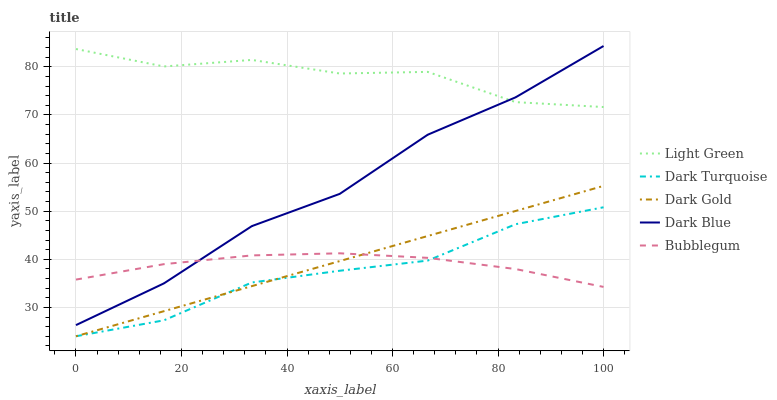Does Dark Turquoise have the minimum area under the curve?
Answer yes or no. Yes. Does Light Green have the maximum area under the curve?
Answer yes or no. Yes. Does Bubblegum have the minimum area under the curve?
Answer yes or no. No. Does Bubblegum have the maximum area under the curve?
Answer yes or no. No. Is Dark Gold the smoothest?
Answer yes or no. Yes. Is Light Green the roughest?
Answer yes or no. Yes. Is Bubblegum the smoothest?
Answer yes or no. No. Is Bubblegum the roughest?
Answer yes or no. No. Does Bubblegum have the lowest value?
Answer yes or no. No. Does Dark Blue have the highest value?
Answer yes or no. Yes. Does Bubblegum have the highest value?
Answer yes or no. No. Is Bubblegum less than Light Green?
Answer yes or no. Yes. Is Dark Blue greater than Dark Gold?
Answer yes or no. Yes. Does Bubblegum intersect Dark Turquoise?
Answer yes or no. Yes. Is Bubblegum less than Dark Turquoise?
Answer yes or no. No. Is Bubblegum greater than Dark Turquoise?
Answer yes or no. No. Does Bubblegum intersect Light Green?
Answer yes or no. No. 